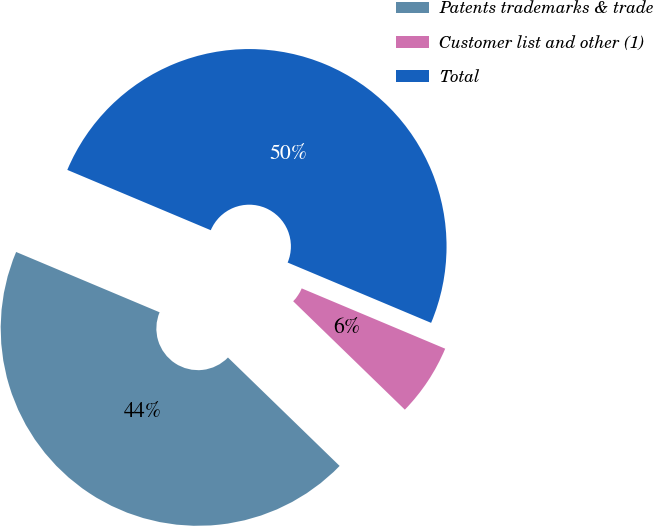<chart> <loc_0><loc_0><loc_500><loc_500><pie_chart><fcel>Patents trademarks & trade<fcel>Customer list and other (1)<fcel>Total<nl><fcel>44.07%<fcel>5.93%<fcel>50.0%<nl></chart> 